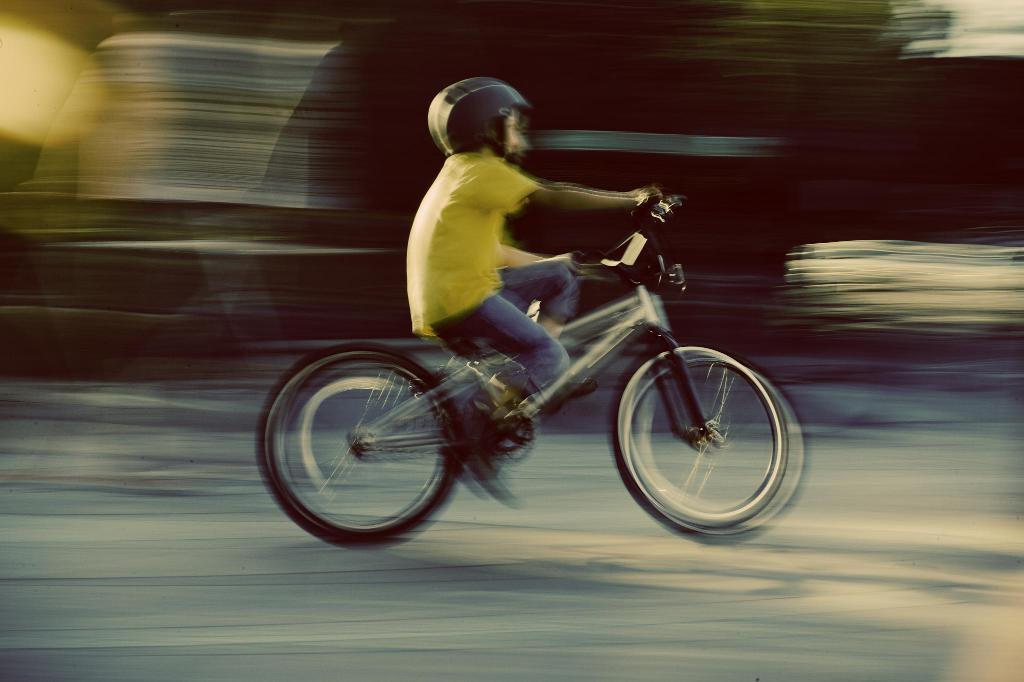What is the main subject of the image? There is a person in the image. What is the person doing in the image? The person is riding a bicycle. Where is the bicycle located? The bicycle is on the road. Which direction is the person riding the bicycle? The person is riding towards the right side. Can you describe the background of the image? The background of the image is blurred. What type of love request can be seen in the image? There is no love request present in the image; it features a person riding a bicycle on the road. What invention is being used by the person in the image? The person in the image is using a bicycle, which is not an invention specific to the image. 